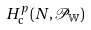<formula> <loc_0><loc_0><loc_500><loc_500>H _ { \text {c} } ^ { p } ( N , \mathcal { P } _ { \mathbb { W } } ) \text { }</formula> 